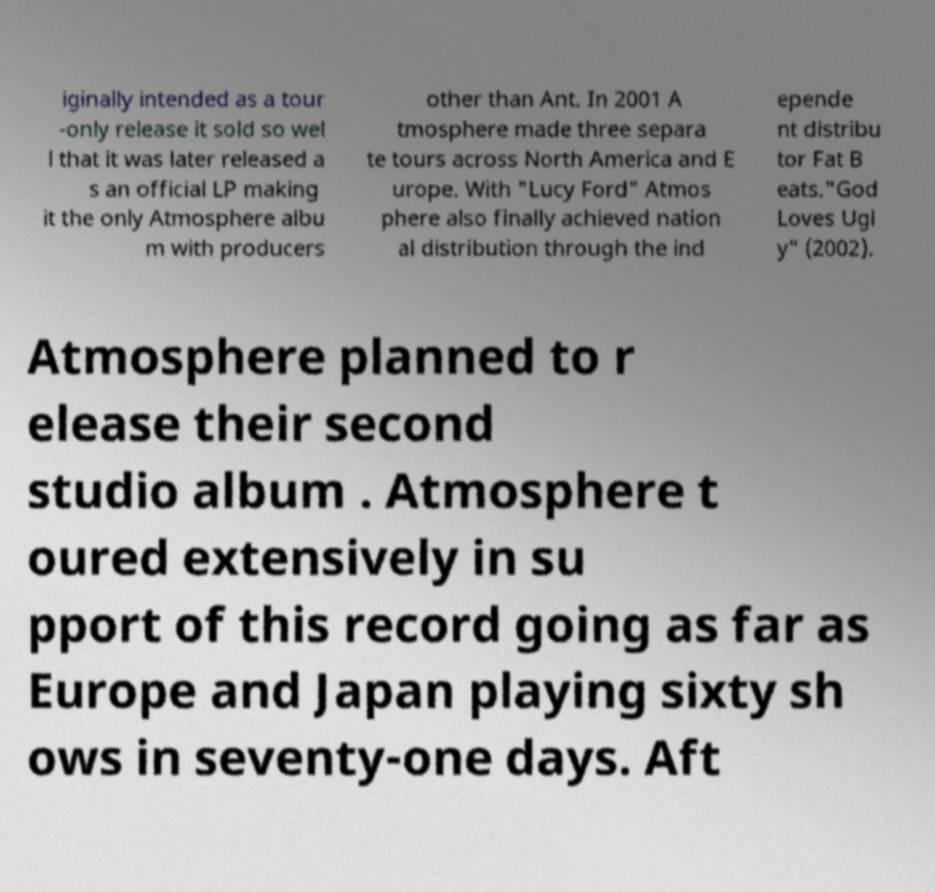I need the written content from this picture converted into text. Can you do that? iginally intended as a tour -only release it sold so wel l that it was later released a s an official LP making it the only Atmosphere albu m with producers other than Ant. In 2001 A tmosphere made three separa te tours across North America and E urope. With "Lucy Ford" Atmos phere also finally achieved nation al distribution through the ind epende nt distribu tor Fat B eats."God Loves Ugl y" (2002). Atmosphere planned to r elease their second studio album . Atmosphere t oured extensively in su pport of this record going as far as Europe and Japan playing sixty sh ows in seventy-one days. Aft 